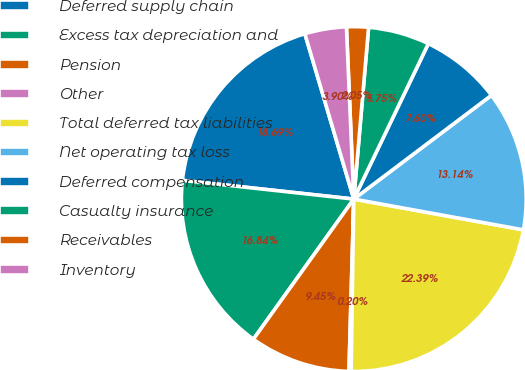Convert chart. <chart><loc_0><loc_0><loc_500><loc_500><pie_chart><fcel>Deferred supply chain<fcel>Excess tax depreciation and<fcel>Pension<fcel>Other<fcel>Total deferred tax liabilities<fcel>Net operating tax loss<fcel>Deferred compensation<fcel>Casualty insurance<fcel>Receivables<fcel>Inventory<nl><fcel>18.69%<fcel>16.84%<fcel>9.45%<fcel>0.2%<fcel>22.39%<fcel>13.14%<fcel>7.6%<fcel>5.75%<fcel>2.05%<fcel>3.9%<nl></chart> 